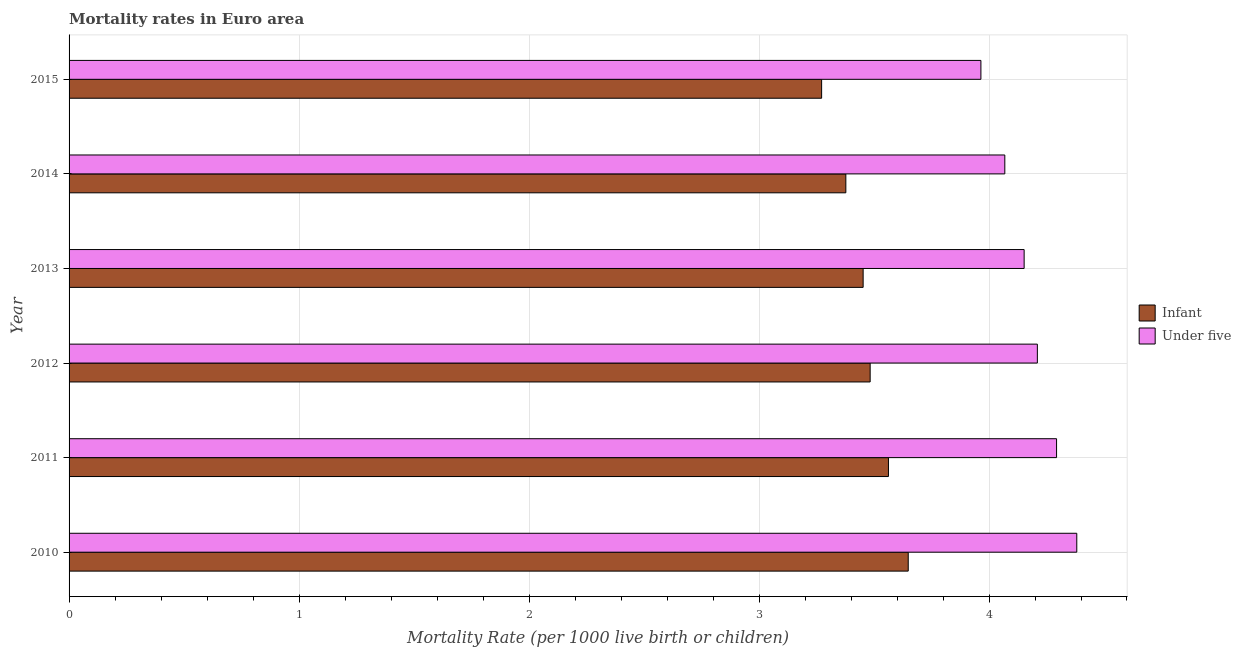How many different coloured bars are there?
Keep it short and to the point. 2. How many groups of bars are there?
Provide a succinct answer. 6. How many bars are there on the 4th tick from the top?
Provide a succinct answer. 2. What is the label of the 2nd group of bars from the top?
Offer a terse response. 2014. What is the infant mortality rate in 2013?
Provide a short and direct response. 3.45. Across all years, what is the maximum infant mortality rate?
Your answer should be compact. 3.65. Across all years, what is the minimum under-5 mortality rate?
Your answer should be compact. 3.96. In which year was the infant mortality rate maximum?
Give a very brief answer. 2010. In which year was the under-5 mortality rate minimum?
Your answer should be very brief. 2015. What is the total infant mortality rate in the graph?
Your answer should be very brief. 20.8. What is the difference between the infant mortality rate in 2010 and that in 2011?
Keep it short and to the point. 0.09. What is the difference between the under-5 mortality rate in 2015 and the infant mortality rate in 2012?
Offer a terse response. 0.48. What is the average under-5 mortality rate per year?
Your response must be concise. 4.18. In the year 2015, what is the difference between the under-5 mortality rate and infant mortality rate?
Your response must be concise. 0.69. In how many years, is the under-5 mortality rate greater than 4 ?
Provide a succinct answer. 5. What is the ratio of the infant mortality rate in 2013 to that in 2014?
Provide a succinct answer. 1.02. Is the under-5 mortality rate in 2010 less than that in 2015?
Keep it short and to the point. No. What is the difference between the highest and the second highest under-5 mortality rate?
Provide a succinct answer. 0.09. What is the difference between the highest and the lowest under-5 mortality rate?
Make the answer very short. 0.42. Is the sum of the infant mortality rate in 2011 and 2012 greater than the maximum under-5 mortality rate across all years?
Give a very brief answer. Yes. What does the 1st bar from the top in 2012 represents?
Your response must be concise. Under five. What does the 2nd bar from the bottom in 2015 represents?
Keep it short and to the point. Under five. How many years are there in the graph?
Keep it short and to the point. 6. What is the difference between two consecutive major ticks on the X-axis?
Offer a terse response. 1. Are the values on the major ticks of X-axis written in scientific E-notation?
Keep it short and to the point. No. Does the graph contain grids?
Make the answer very short. Yes. Where does the legend appear in the graph?
Provide a succinct answer. Center right. How are the legend labels stacked?
Your response must be concise. Vertical. What is the title of the graph?
Your response must be concise. Mortality rates in Euro area. Does "National Visitors" appear as one of the legend labels in the graph?
Provide a succinct answer. No. What is the label or title of the X-axis?
Offer a terse response. Mortality Rate (per 1000 live birth or children). What is the Mortality Rate (per 1000 live birth or children) of Infant in 2010?
Provide a succinct answer. 3.65. What is the Mortality Rate (per 1000 live birth or children) of Under five in 2010?
Ensure brevity in your answer.  4.38. What is the Mortality Rate (per 1000 live birth or children) of Infant in 2011?
Make the answer very short. 3.56. What is the Mortality Rate (per 1000 live birth or children) of Under five in 2011?
Your answer should be very brief. 4.29. What is the Mortality Rate (per 1000 live birth or children) of Infant in 2012?
Your answer should be very brief. 3.48. What is the Mortality Rate (per 1000 live birth or children) of Under five in 2012?
Offer a terse response. 4.21. What is the Mortality Rate (per 1000 live birth or children) in Infant in 2013?
Your answer should be very brief. 3.45. What is the Mortality Rate (per 1000 live birth or children) in Under five in 2013?
Your response must be concise. 4.15. What is the Mortality Rate (per 1000 live birth or children) of Infant in 2014?
Provide a short and direct response. 3.38. What is the Mortality Rate (per 1000 live birth or children) of Under five in 2014?
Your answer should be compact. 4.07. What is the Mortality Rate (per 1000 live birth or children) of Infant in 2015?
Provide a short and direct response. 3.27. What is the Mortality Rate (per 1000 live birth or children) in Under five in 2015?
Give a very brief answer. 3.96. Across all years, what is the maximum Mortality Rate (per 1000 live birth or children) of Infant?
Your answer should be compact. 3.65. Across all years, what is the maximum Mortality Rate (per 1000 live birth or children) in Under five?
Give a very brief answer. 4.38. Across all years, what is the minimum Mortality Rate (per 1000 live birth or children) in Infant?
Offer a very short reply. 3.27. Across all years, what is the minimum Mortality Rate (per 1000 live birth or children) in Under five?
Provide a short and direct response. 3.96. What is the total Mortality Rate (per 1000 live birth or children) in Infant in the graph?
Your answer should be very brief. 20.8. What is the total Mortality Rate (per 1000 live birth or children) of Under five in the graph?
Provide a short and direct response. 25.07. What is the difference between the Mortality Rate (per 1000 live birth or children) in Infant in 2010 and that in 2011?
Provide a succinct answer. 0.09. What is the difference between the Mortality Rate (per 1000 live birth or children) of Under five in 2010 and that in 2011?
Keep it short and to the point. 0.09. What is the difference between the Mortality Rate (per 1000 live birth or children) of Infant in 2010 and that in 2012?
Your response must be concise. 0.17. What is the difference between the Mortality Rate (per 1000 live birth or children) of Under five in 2010 and that in 2012?
Your answer should be very brief. 0.17. What is the difference between the Mortality Rate (per 1000 live birth or children) in Infant in 2010 and that in 2013?
Offer a very short reply. 0.2. What is the difference between the Mortality Rate (per 1000 live birth or children) of Under five in 2010 and that in 2013?
Ensure brevity in your answer.  0.23. What is the difference between the Mortality Rate (per 1000 live birth or children) of Infant in 2010 and that in 2014?
Offer a very short reply. 0.27. What is the difference between the Mortality Rate (per 1000 live birth or children) of Under five in 2010 and that in 2014?
Offer a terse response. 0.31. What is the difference between the Mortality Rate (per 1000 live birth or children) of Infant in 2010 and that in 2015?
Make the answer very short. 0.38. What is the difference between the Mortality Rate (per 1000 live birth or children) of Under five in 2010 and that in 2015?
Provide a short and direct response. 0.42. What is the difference between the Mortality Rate (per 1000 live birth or children) in Infant in 2011 and that in 2012?
Your response must be concise. 0.08. What is the difference between the Mortality Rate (per 1000 live birth or children) of Under five in 2011 and that in 2012?
Offer a very short reply. 0.08. What is the difference between the Mortality Rate (per 1000 live birth or children) in Infant in 2011 and that in 2013?
Make the answer very short. 0.11. What is the difference between the Mortality Rate (per 1000 live birth or children) in Under five in 2011 and that in 2013?
Keep it short and to the point. 0.14. What is the difference between the Mortality Rate (per 1000 live birth or children) of Infant in 2011 and that in 2014?
Ensure brevity in your answer.  0.19. What is the difference between the Mortality Rate (per 1000 live birth or children) in Under five in 2011 and that in 2014?
Your response must be concise. 0.23. What is the difference between the Mortality Rate (per 1000 live birth or children) of Infant in 2011 and that in 2015?
Provide a short and direct response. 0.29. What is the difference between the Mortality Rate (per 1000 live birth or children) of Under five in 2011 and that in 2015?
Provide a short and direct response. 0.33. What is the difference between the Mortality Rate (per 1000 live birth or children) in Infant in 2012 and that in 2013?
Give a very brief answer. 0.03. What is the difference between the Mortality Rate (per 1000 live birth or children) in Under five in 2012 and that in 2013?
Your response must be concise. 0.06. What is the difference between the Mortality Rate (per 1000 live birth or children) of Infant in 2012 and that in 2014?
Keep it short and to the point. 0.11. What is the difference between the Mortality Rate (per 1000 live birth or children) of Under five in 2012 and that in 2014?
Provide a succinct answer. 0.14. What is the difference between the Mortality Rate (per 1000 live birth or children) in Infant in 2012 and that in 2015?
Make the answer very short. 0.21. What is the difference between the Mortality Rate (per 1000 live birth or children) of Under five in 2012 and that in 2015?
Offer a terse response. 0.25. What is the difference between the Mortality Rate (per 1000 live birth or children) of Infant in 2013 and that in 2014?
Provide a succinct answer. 0.08. What is the difference between the Mortality Rate (per 1000 live birth or children) of Under five in 2013 and that in 2014?
Your response must be concise. 0.08. What is the difference between the Mortality Rate (per 1000 live birth or children) of Infant in 2013 and that in 2015?
Offer a terse response. 0.18. What is the difference between the Mortality Rate (per 1000 live birth or children) in Under five in 2013 and that in 2015?
Your answer should be very brief. 0.19. What is the difference between the Mortality Rate (per 1000 live birth or children) in Infant in 2014 and that in 2015?
Provide a short and direct response. 0.11. What is the difference between the Mortality Rate (per 1000 live birth or children) of Under five in 2014 and that in 2015?
Your answer should be very brief. 0.1. What is the difference between the Mortality Rate (per 1000 live birth or children) of Infant in 2010 and the Mortality Rate (per 1000 live birth or children) of Under five in 2011?
Provide a short and direct response. -0.64. What is the difference between the Mortality Rate (per 1000 live birth or children) in Infant in 2010 and the Mortality Rate (per 1000 live birth or children) in Under five in 2012?
Offer a very short reply. -0.56. What is the difference between the Mortality Rate (per 1000 live birth or children) in Infant in 2010 and the Mortality Rate (per 1000 live birth or children) in Under five in 2013?
Provide a short and direct response. -0.5. What is the difference between the Mortality Rate (per 1000 live birth or children) in Infant in 2010 and the Mortality Rate (per 1000 live birth or children) in Under five in 2014?
Your response must be concise. -0.42. What is the difference between the Mortality Rate (per 1000 live birth or children) of Infant in 2010 and the Mortality Rate (per 1000 live birth or children) of Under five in 2015?
Your answer should be very brief. -0.32. What is the difference between the Mortality Rate (per 1000 live birth or children) of Infant in 2011 and the Mortality Rate (per 1000 live birth or children) of Under five in 2012?
Make the answer very short. -0.65. What is the difference between the Mortality Rate (per 1000 live birth or children) of Infant in 2011 and the Mortality Rate (per 1000 live birth or children) of Under five in 2013?
Your response must be concise. -0.59. What is the difference between the Mortality Rate (per 1000 live birth or children) of Infant in 2011 and the Mortality Rate (per 1000 live birth or children) of Under five in 2014?
Your answer should be very brief. -0.51. What is the difference between the Mortality Rate (per 1000 live birth or children) in Infant in 2011 and the Mortality Rate (per 1000 live birth or children) in Under five in 2015?
Give a very brief answer. -0.4. What is the difference between the Mortality Rate (per 1000 live birth or children) of Infant in 2012 and the Mortality Rate (per 1000 live birth or children) of Under five in 2013?
Keep it short and to the point. -0.67. What is the difference between the Mortality Rate (per 1000 live birth or children) of Infant in 2012 and the Mortality Rate (per 1000 live birth or children) of Under five in 2014?
Your response must be concise. -0.59. What is the difference between the Mortality Rate (per 1000 live birth or children) in Infant in 2012 and the Mortality Rate (per 1000 live birth or children) in Under five in 2015?
Make the answer very short. -0.48. What is the difference between the Mortality Rate (per 1000 live birth or children) of Infant in 2013 and the Mortality Rate (per 1000 live birth or children) of Under five in 2014?
Your response must be concise. -0.62. What is the difference between the Mortality Rate (per 1000 live birth or children) in Infant in 2013 and the Mortality Rate (per 1000 live birth or children) in Under five in 2015?
Provide a succinct answer. -0.51. What is the difference between the Mortality Rate (per 1000 live birth or children) in Infant in 2014 and the Mortality Rate (per 1000 live birth or children) in Under five in 2015?
Offer a terse response. -0.59. What is the average Mortality Rate (per 1000 live birth or children) of Infant per year?
Keep it short and to the point. 3.47. What is the average Mortality Rate (per 1000 live birth or children) of Under five per year?
Offer a very short reply. 4.18. In the year 2010, what is the difference between the Mortality Rate (per 1000 live birth or children) in Infant and Mortality Rate (per 1000 live birth or children) in Under five?
Offer a terse response. -0.73. In the year 2011, what is the difference between the Mortality Rate (per 1000 live birth or children) of Infant and Mortality Rate (per 1000 live birth or children) of Under five?
Your answer should be very brief. -0.73. In the year 2012, what is the difference between the Mortality Rate (per 1000 live birth or children) in Infant and Mortality Rate (per 1000 live birth or children) in Under five?
Give a very brief answer. -0.73. In the year 2013, what is the difference between the Mortality Rate (per 1000 live birth or children) in Infant and Mortality Rate (per 1000 live birth or children) in Under five?
Your answer should be very brief. -0.7. In the year 2014, what is the difference between the Mortality Rate (per 1000 live birth or children) of Infant and Mortality Rate (per 1000 live birth or children) of Under five?
Ensure brevity in your answer.  -0.69. In the year 2015, what is the difference between the Mortality Rate (per 1000 live birth or children) in Infant and Mortality Rate (per 1000 live birth or children) in Under five?
Your response must be concise. -0.69. What is the ratio of the Mortality Rate (per 1000 live birth or children) of Infant in 2010 to that in 2011?
Give a very brief answer. 1.02. What is the ratio of the Mortality Rate (per 1000 live birth or children) in Under five in 2010 to that in 2011?
Provide a succinct answer. 1.02. What is the ratio of the Mortality Rate (per 1000 live birth or children) in Infant in 2010 to that in 2012?
Make the answer very short. 1.05. What is the ratio of the Mortality Rate (per 1000 live birth or children) of Under five in 2010 to that in 2012?
Provide a short and direct response. 1.04. What is the ratio of the Mortality Rate (per 1000 live birth or children) in Infant in 2010 to that in 2013?
Make the answer very short. 1.06. What is the ratio of the Mortality Rate (per 1000 live birth or children) of Under five in 2010 to that in 2013?
Ensure brevity in your answer.  1.06. What is the ratio of the Mortality Rate (per 1000 live birth or children) in Infant in 2010 to that in 2014?
Your response must be concise. 1.08. What is the ratio of the Mortality Rate (per 1000 live birth or children) of Infant in 2010 to that in 2015?
Offer a very short reply. 1.12. What is the ratio of the Mortality Rate (per 1000 live birth or children) of Under five in 2010 to that in 2015?
Give a very brief answer. 1.11. What is the ratio of the Mortality Rate (per 1000 live birth or children) of Infant in 2011 to that in 2012?
Your answer should be very brief. 1.02. What is the ratio of the Mortality Rate (per 1000 live birth or children) in Under five in 2011 to that in 2012?
Offer a very short reply. 1.02. What is the ratio of the Mortality Rate (per 1000 live birth or children) of Infant in 2011 to that in 2013?
Provide a short and direct response. 1.03. What is the ratio of the Mortality Rate (per 1000 live birth or children) in Under five in 2011 to that in 2013?
Your answer should be very brief. 1.03. What is the ratio of the Mortality Rate (per 1000 live birth or children) of Infant in 2011 to that in 2014?
Give a very brief answer. 1.05. What is the ratio of the Mortality Rate (per 1000 live birth or children) of Under five in 2011 to that in 2014?
Offer a terse response. 1.06. What is the ratio of the Mortality Rate (per 1000 live birth or children) in Infant in 2011 to that in 2015?
Ensure brevity in your answer.  1.09. What is the ratio of the Mortality Rate (per 1000 live birth or children) in Under five in 2011 to that in 2015?
Keep it short and to the point. 1.08. What is the ratio of the Mortality Rate (per 1000 live birth or children) in Infant in 2012 to that in 2013?
Your answer should be compact. 1.01. What is the ratio of the Mortality Rate (per 1000 live birth or children) of Under five in 2012 to that in 2013?
Ensure brevity in your answer.  1.01. What is the ratio of the Mortality Rate (per 1000 live birth or children) of Infant in 2012 to that in 2014?
Ensure brevity in your answer.  1.03. What is the ratio of the Mortality Rate (per 1000 live birth or children) of Under five in 2012 to that in 2014?
Your answer should be compact. 1.03. What is the ratio of the Mortality Rate (per 1000 live birth or children) in Infant in 2012 to that in 2015?
Provide a short and direct response. 1.06. What is the ratio of the Mortality Rate (per 1000 live birth or children) of Under five in 2012 to that in 2015?
Your answer should be compact. 1.06. What is the ratio of the Mortality Rate (per 1000 live birth or children) in Infant in 2013 to that in 2014?
Make the answer very short. 1.02. What is the ratio of the Mortality Rate (per 1000 live birth or children) in Under five in 2013 to that in 2014?
Your response must be concise. 1.02. What is the ratio of the Mortality Rate (per 1000 live birth or children) of Infant in 2013 to that in 2015?
Your response must be concise. 1.06. What is the ratio of the Mortality Rate (per 1000 live birth or children) of Under five in 2013 to that in 2015?
Provide a short and direct response. 1.05. What is the ratio of the Mortality Rate (per 1000 live birth or children) of Infant in 2014 to that in 2015?
Provide a succinct answer. 1.03. What is the ratio of the Mortality Rate (per 1000 live birth or children) in Under five in 2014 to that in 2015?
Your answer should be compact. 1.03. What is the difference between the highest and the second highest Mortality Rate (per 1000 live birth or children) of Infant?
Give a very brief answer. 0.09. What is the difference between the highest and the second highest Mortality Rate (per 1000 live birth or children) in Under five?
Ensure brevity in your answer.  0.09. What is the difference between the highest and the lowest Mortality Rate (per 1000 live birth or children) in Infant?
Provide a succinct answer. 0.38. What is the difference between the highest and the lowest Mortality Rate (per 1000 live birth or children) of Under five?
Offer a terse response. 0.42. 